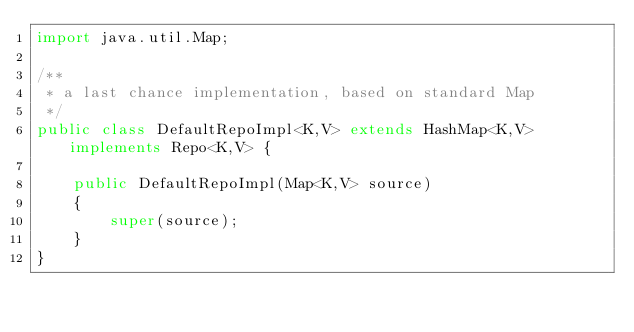<code> <loc_0><loc_0><loc_500><loc_500><_Java_>import java.util.Map;

/**
 * a last chance implementation, based on standard Map
 */
public class DefaultRepoImpl<K,V> extends HashMap<K,V> implements Repo<K,V> {

    public DefaultRepoImpl(Map<K,V> source)
    {
        super(source);
    }
}
</code> 